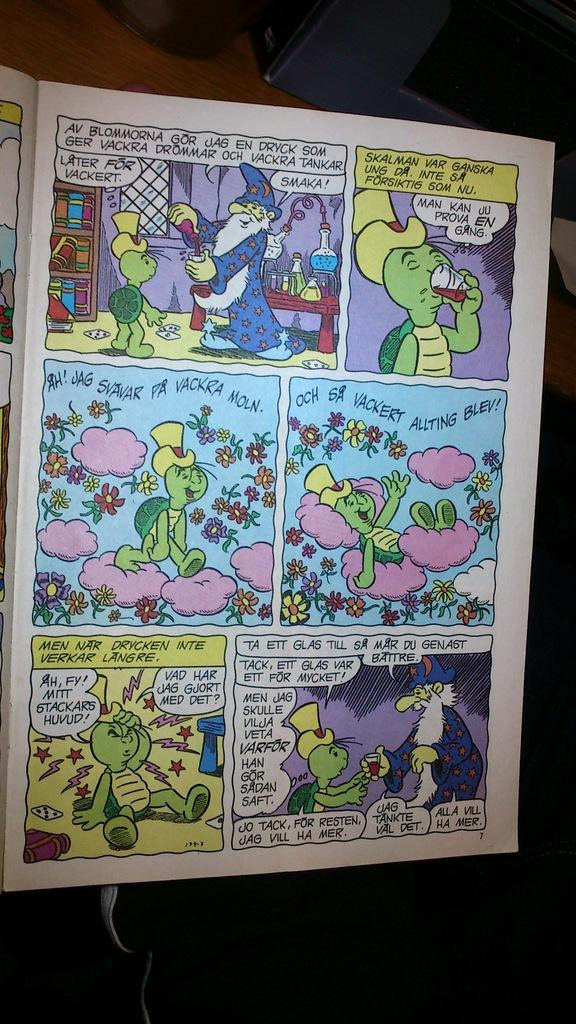<image>
Provide a brief description of the given image. Comic with a turtle saying "Man Kan JU Prova En Gang" which appears to be a foreign language. 